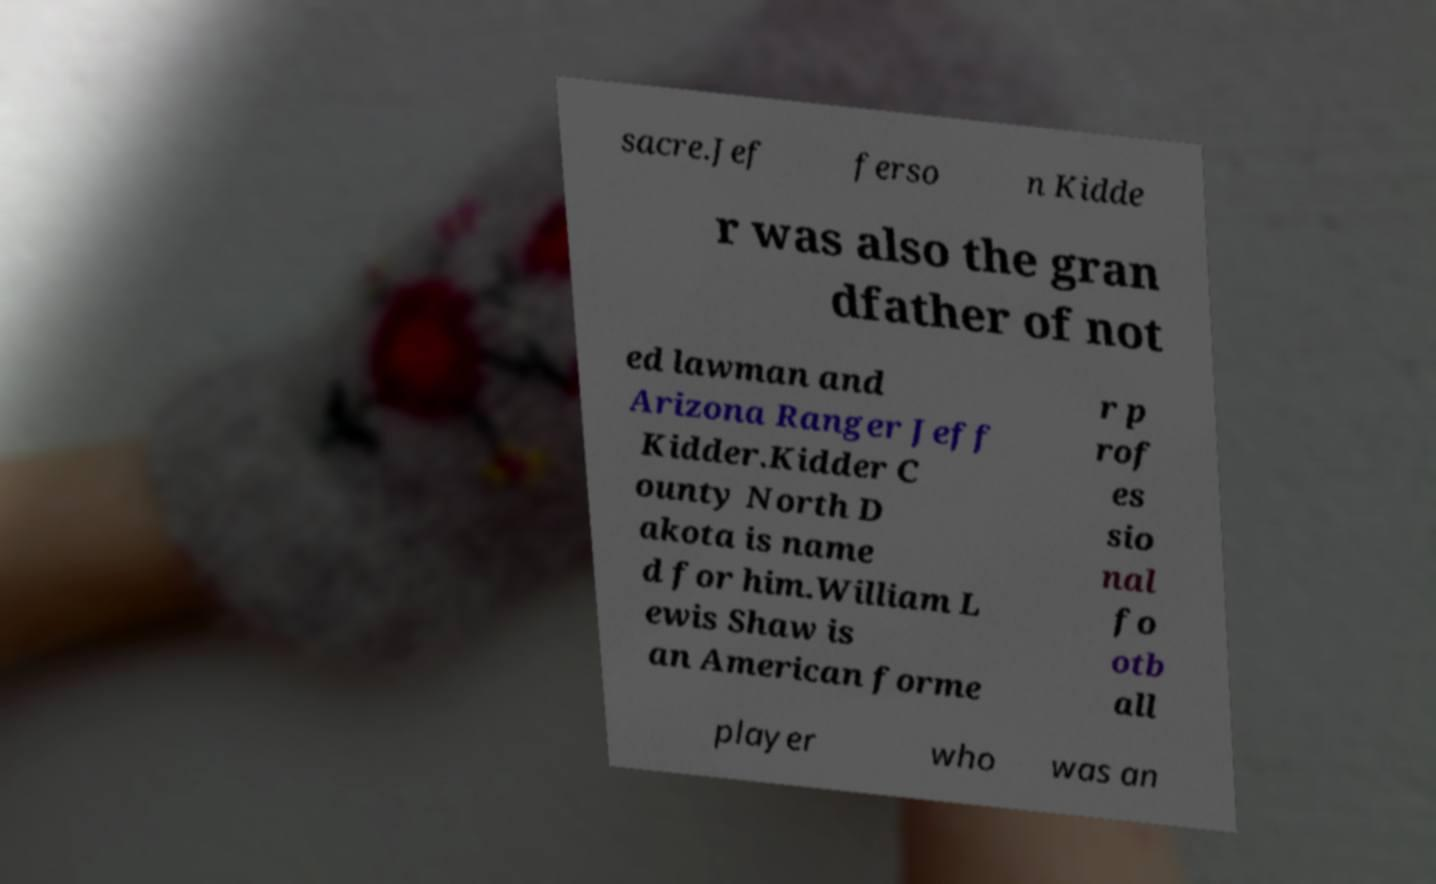What messages or text are displayed in this image? I need them in a readable, typed format. sacre.Jef ferso n Kidde r was also the gran dfather of not ed lawman and Arizona Ranger Jeff Kidder.Kidder C ounty North D akota is name d for him.William L ewis Shaw is an American forme r p rof es sio nal fo otb all player who was an 